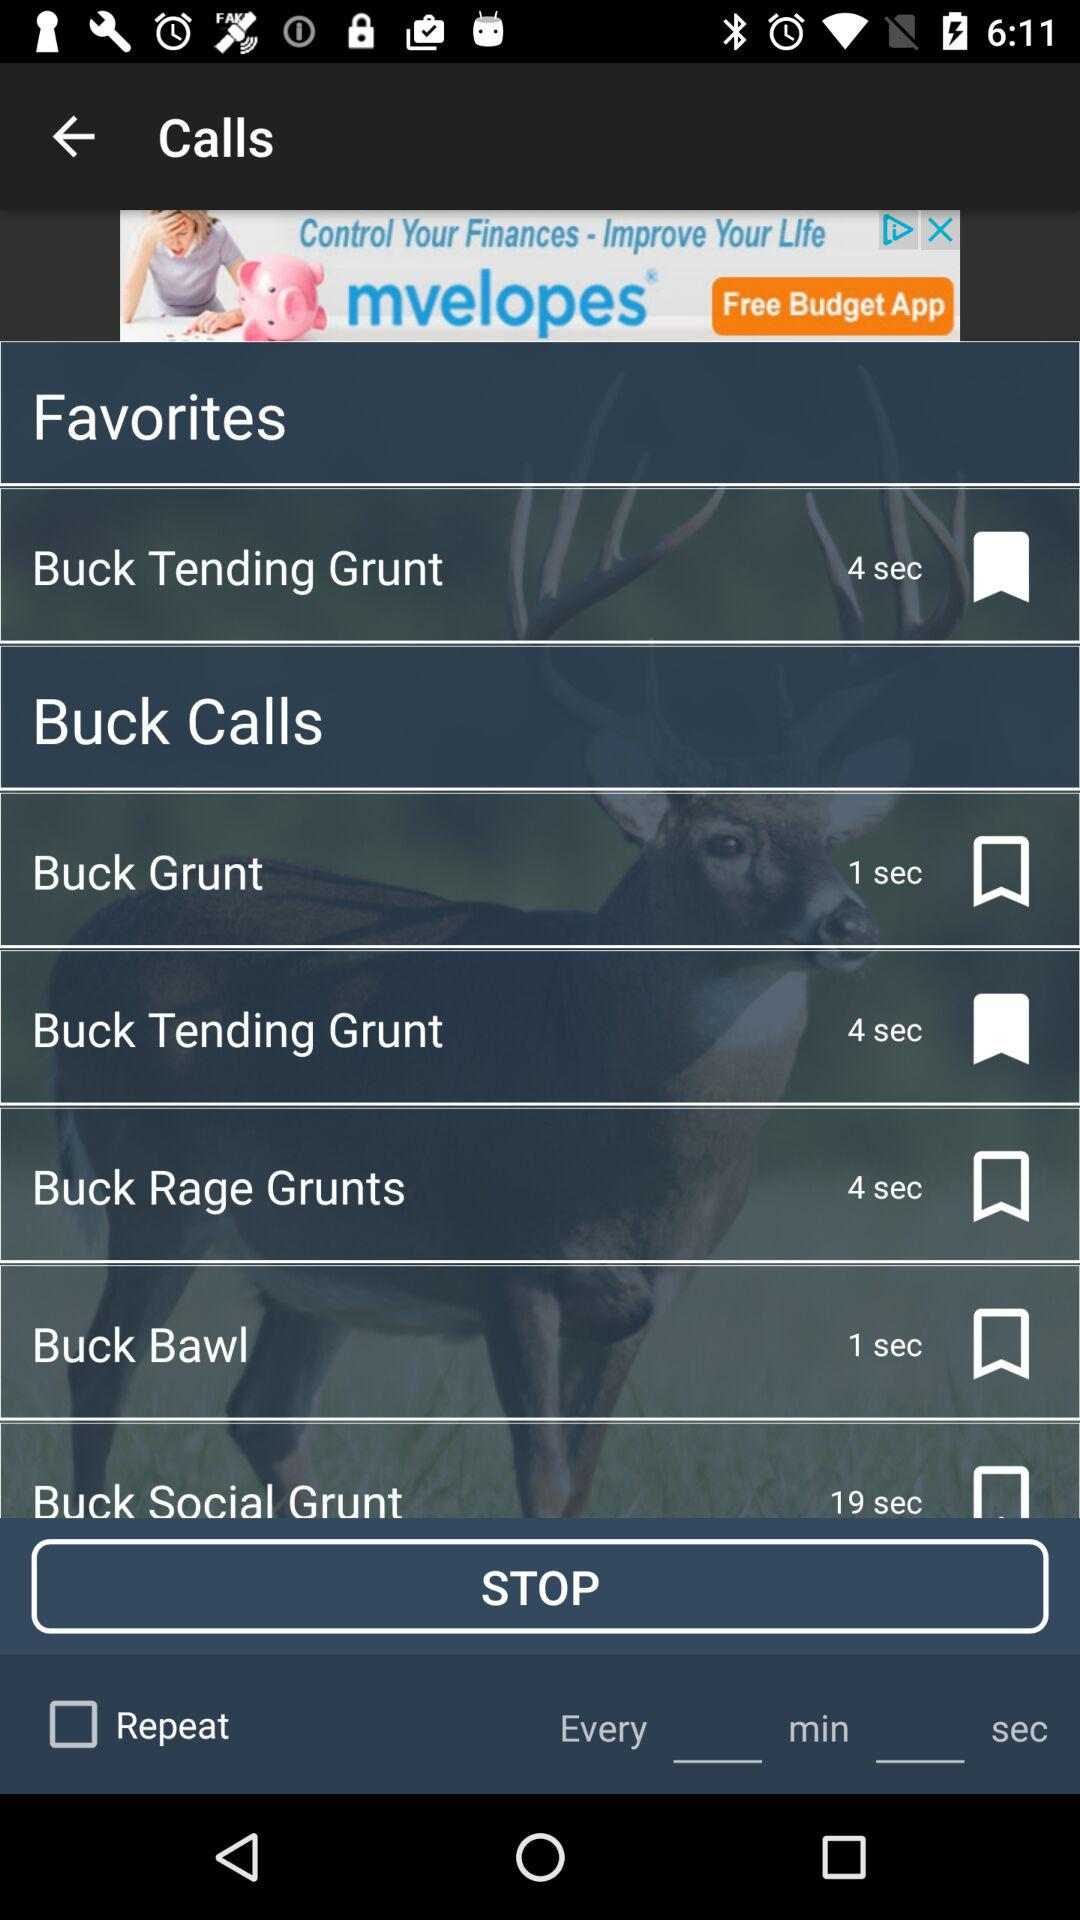What is the call duration for Buck Bawl? The call duration is 1 second. 